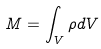Convert formula to latex. <formula><loc_0><loc_0><loc_500><loc_500>M = \int _ { V } \rho d V</formula> 